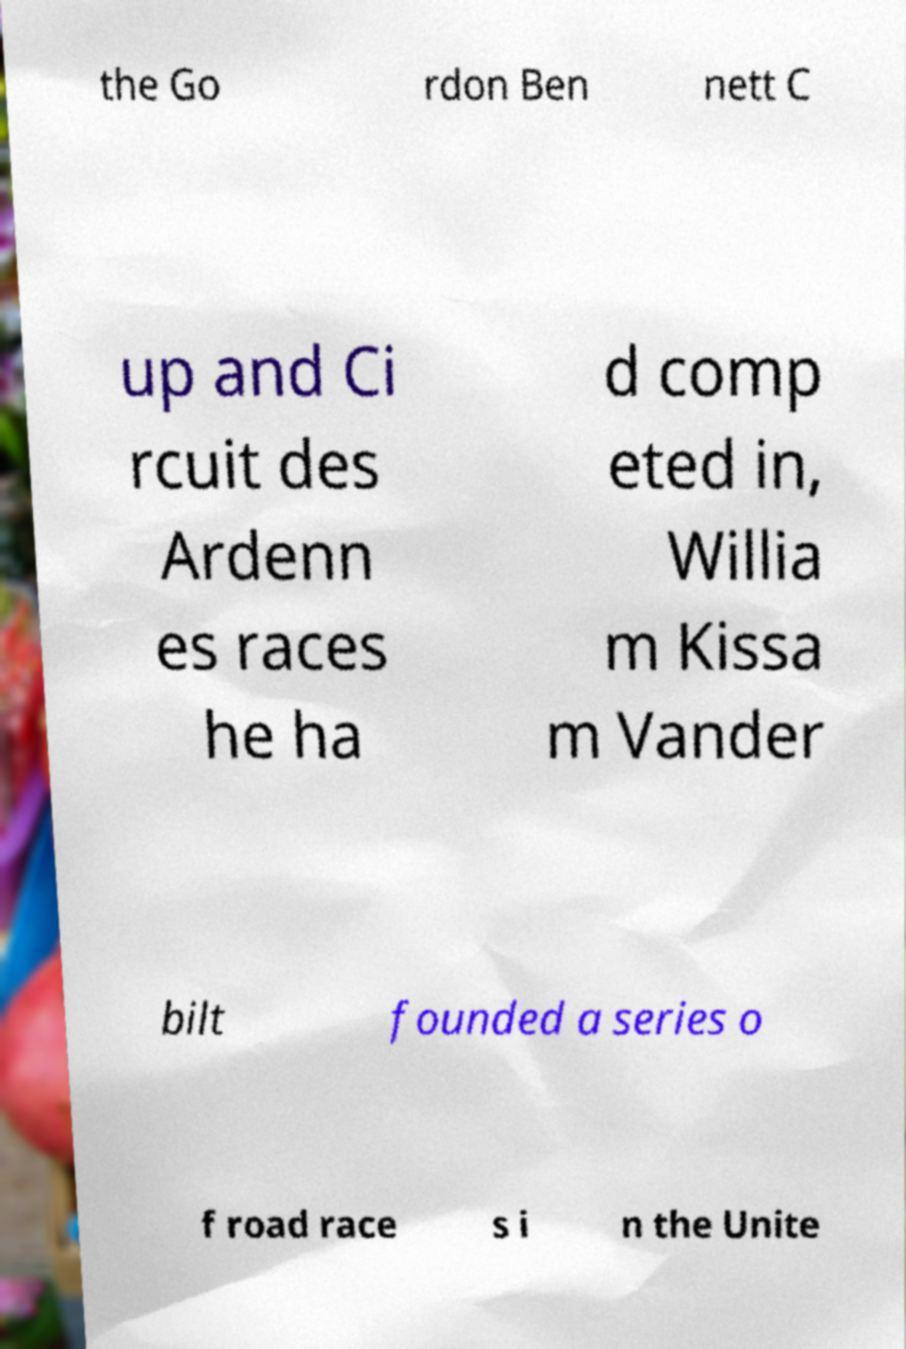Can you accurately transcribe the text from the provided image for me? the Go rdon Ben nett C up and Ci rcuit des Ardenn es races he ha d comp eted in, Willia m Kissa m Vander bilt founded a series o f road race s i n the Unite 